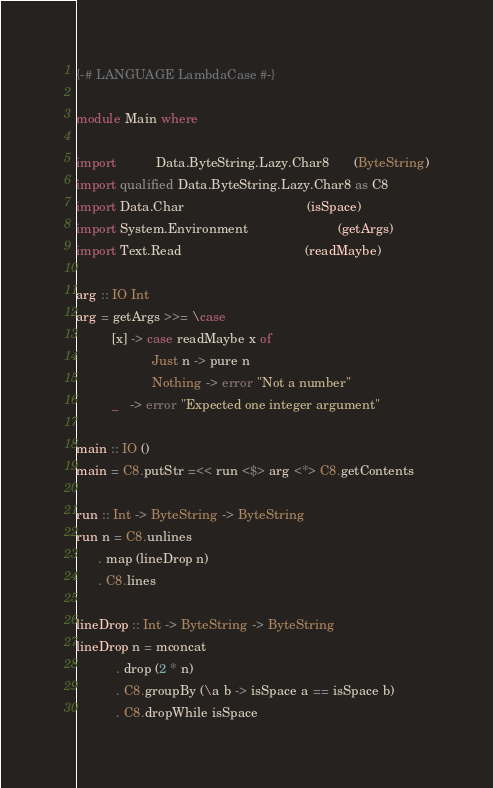<code> <loc_0><loc_0><loc_500><loc_500><_Haskell_>{-# LANGUAGE LambdaCase #-}

module Main where

import           Data.ByteString.Lazy.Char8       (ByteString)
import qualified Data.ByteString.Lazy.Char8 as C8
import Data.Char                                  (isSpace)
import System.Environment                         (getArgs)
import Text.Read                                  (readMaybe)

arg :: IO Int
arg = getArgs >>= \case
          [x] -> case readMaybe x of
                     Just n -> pure n
                     Nothing -> error "Not a number"
          _   -> error "Expected one integer argument"

main :: IO ()
main = C8.putStr =<< run <$> arg <*> C8.getContents

run :: Int -> ByteString -> ByteString
run n = C8.unlines
      . map (lineDrop n)
      . C8.lines

lineDrop :: Int -> ByteString -> ByteString
lineDrop n = mconcat
           . drop (2 * n)
           . C8.groupBy (\a b -> isSpace a == isSpace b)
           . C8.dropWhile isSpace
</code> 